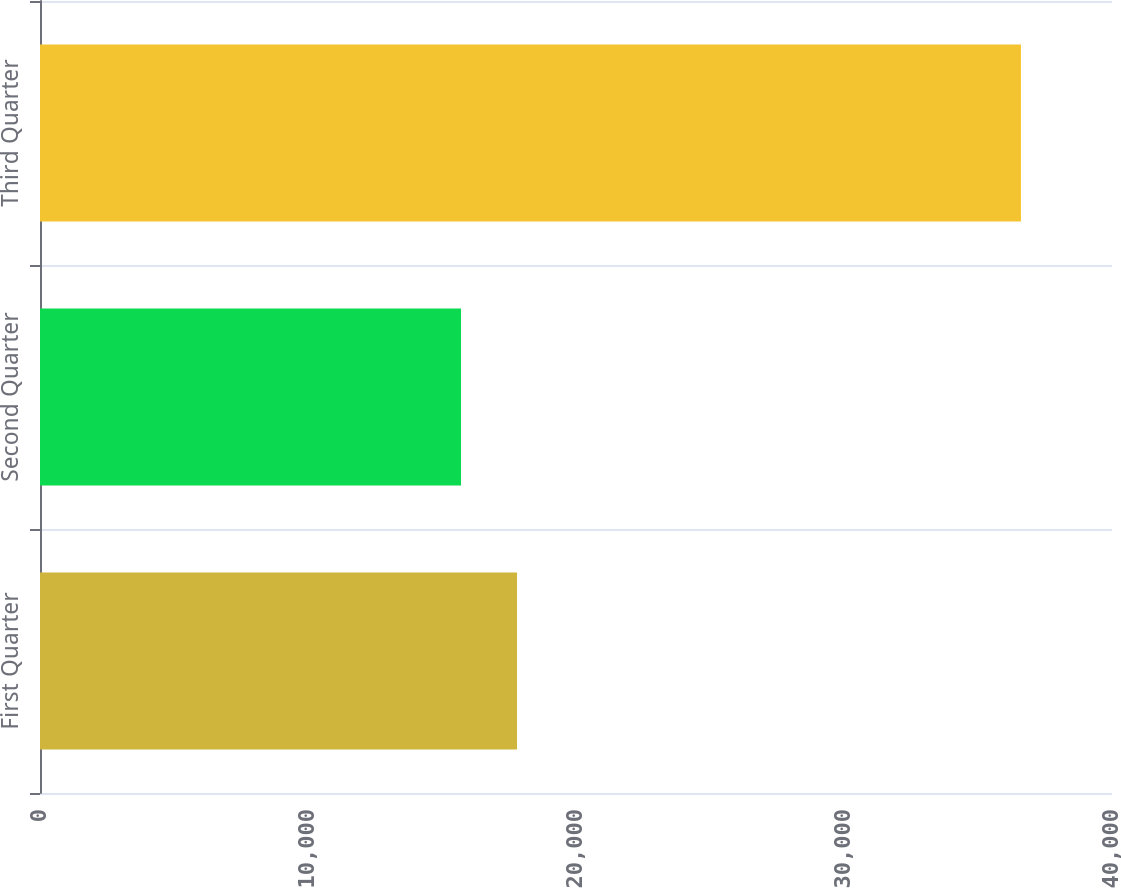<chart> <loc_0><loc_0><loc_500><loc_500><bar_chart><fcel>First Quarter<fcel>Second Quarter<fcel>Third Quarter<nl><fcel>17799.3<fcel>15710<fcel>36603<nl></chart> 